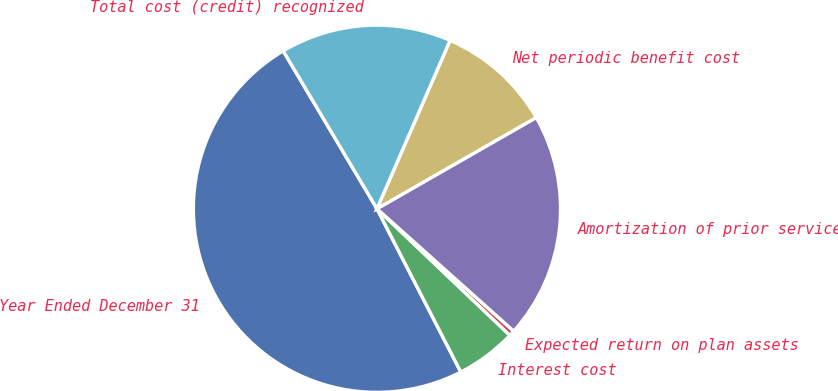Convert chart. <chart><loc_0><loc_0><loc_500><loc_500><pie_chart><fcel>Year Ended December 31<fcel>Interest cost<fcel>Expected return on plan assets<fcel>Amortization of prior service<fcel>Net periodic benefit cost<fcel>Total cost (credit) recognized<nl><fcel>49.02%<fcel>5.34%<fcel>0.49%<fcel>19.9%<fcel>10.2%<fcel>15.05%<nl></chart> 